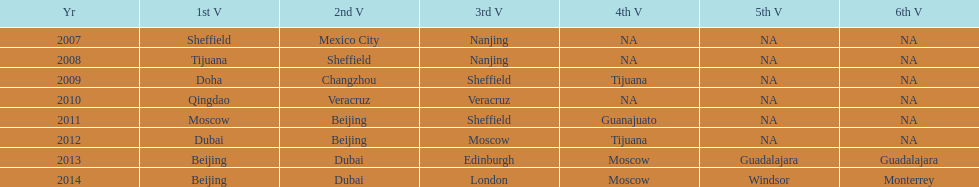What years had the most venues? 2013, 2014. 